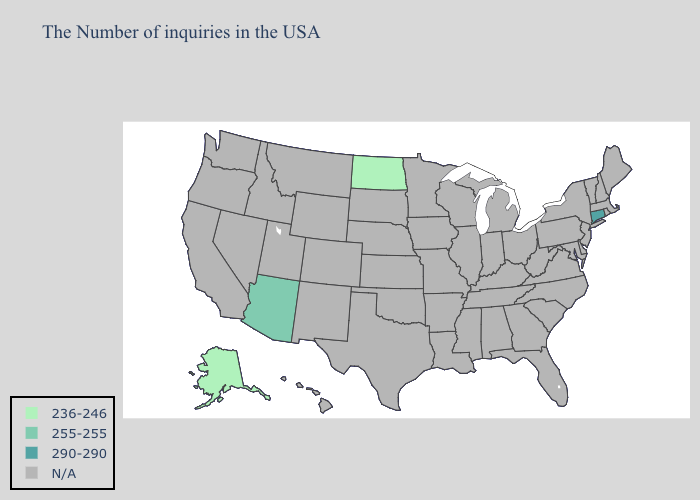Does the map have missing data?
Keep it brief. Yes. Which states have the lowest value in the USA?
Answer briefly. North Dakota, Alaska. What is the lowest value in the USA?
Answer briefly. 236-246. What is the value of Maine?
Be succinct. N/A. Name the states that have a value in the range 236-246?
Write a very short answer. North Dakota, Alaska. How many symbols are there in the legend?
Short answer required. 4. Does Arizona have the lowest value in the West?
Write a very short answer. No. Name the states that have a value in the range N/A?
Give a very brief answer. Maine, Massachusetts, Rhode Island, New Hampshire, Vermont, New York, New Jersey, Delaware, Maryland, Pennsylvania, Virginia, North Carolina, South Carolina, West Virginia, Ohio, Florida, Georgia, Michigan, Kentucky, Indiana, Alabama, Tennessee, Wisconsin, Illinois, Mississippi, Louisiana, Missouri, Arkansas, Minnesota, Iowa, Kansas, Nebraska, Oklahoma, Texas, South Dakota, Wyoming, Colorado, New Mexico, Utah, Montana, Idaho, Nevada, California, Washington, Oregon, Hawaii. Name the states that have a value in the range 255-255?
Be succinct. Arizona. What is the value of Nevada?
Concise answer only. N/A. What is the value of Tennessee?
Short answer required. N/A. 